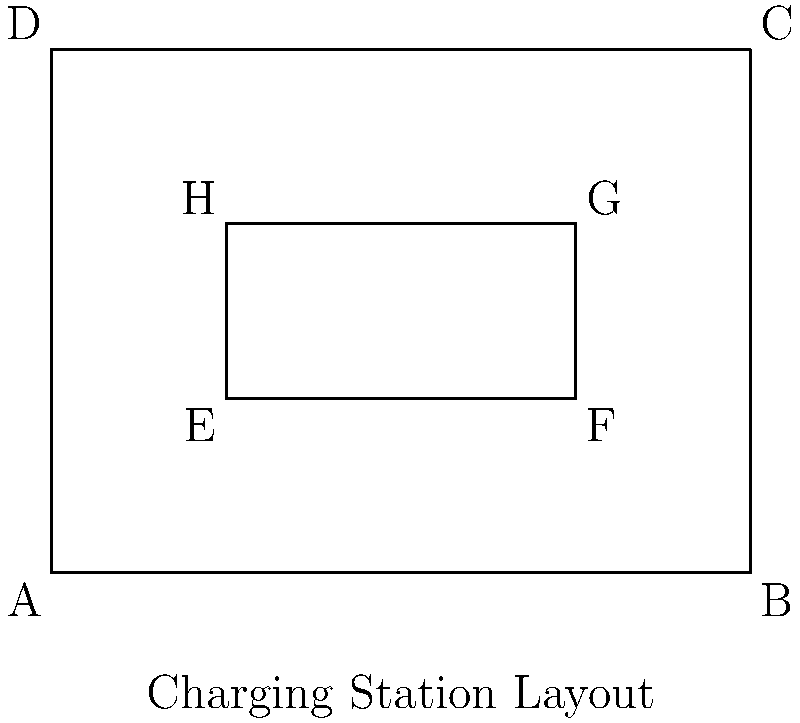In the diagram of an electric vehicle charging station layout, which two shapes are congruent? To determine which shapes are congruent in the charging station layout, we need to follow these steps:

1. Identify the shapes in the diagram:
   - Rectangle ABCD (outer rectangle)
   - Rectangle EFGH (inner rectangle)

2. Recall the definition of congruent shapes:
   Two shapes are congruent if they have the same size and shape.

3. Analyze the properties of the rectangles:
   - Rectangle ABCD: 
     Length = 4 units (from A to B)
     Width = 3 units (from A to D)
   - Rectangle EFGH:
     Length = 2 units (from E to F)
     Width = 1 unit (from E to H)

4. Compare the rectangles:
   - The two rectangles have different dimensions.
   - Their sizes are not the same.

5. Look for other potential congruent shapes:
   - There are no other distinct shapes in the diagram.

6. Conclusion:
   There are no congruent shapes in this charging station layout.
Answer: No congruent shapes 